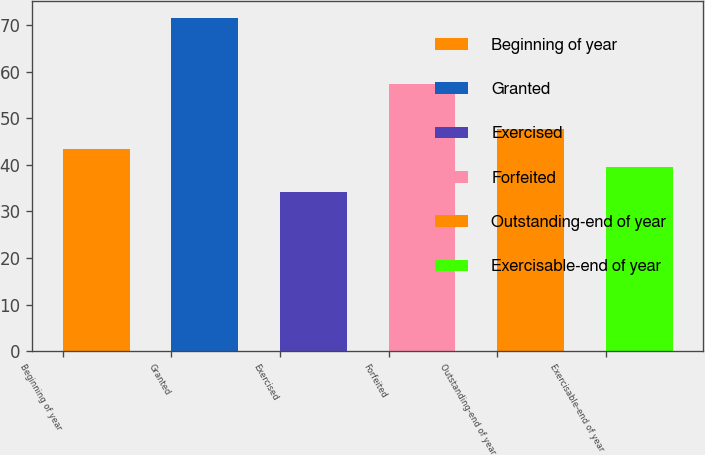Convert chart. <chart><loc_0><loc_0><loc_500><loc_500><bar_chart><fcel>Beginning of year<fcel>Granted<fcel>Exercised<fcel>Forfeited<fcel>Outstanding-end of year<fcel>Exercisable-end of year<nl><fcel>43.37<fcel>71.6<fcel>34.11<fcel>57.33<fcel>47.73<fcel>39.62<nl></chart> 